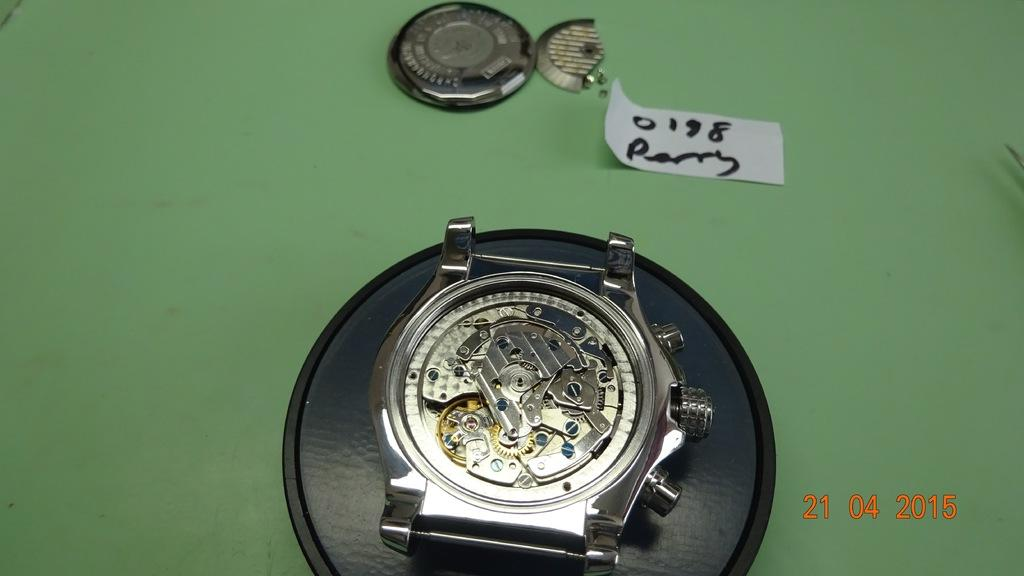<image>
Share a concise interpretation of the image provided. A piece of paper that says perry above a watch with its cover removed. 